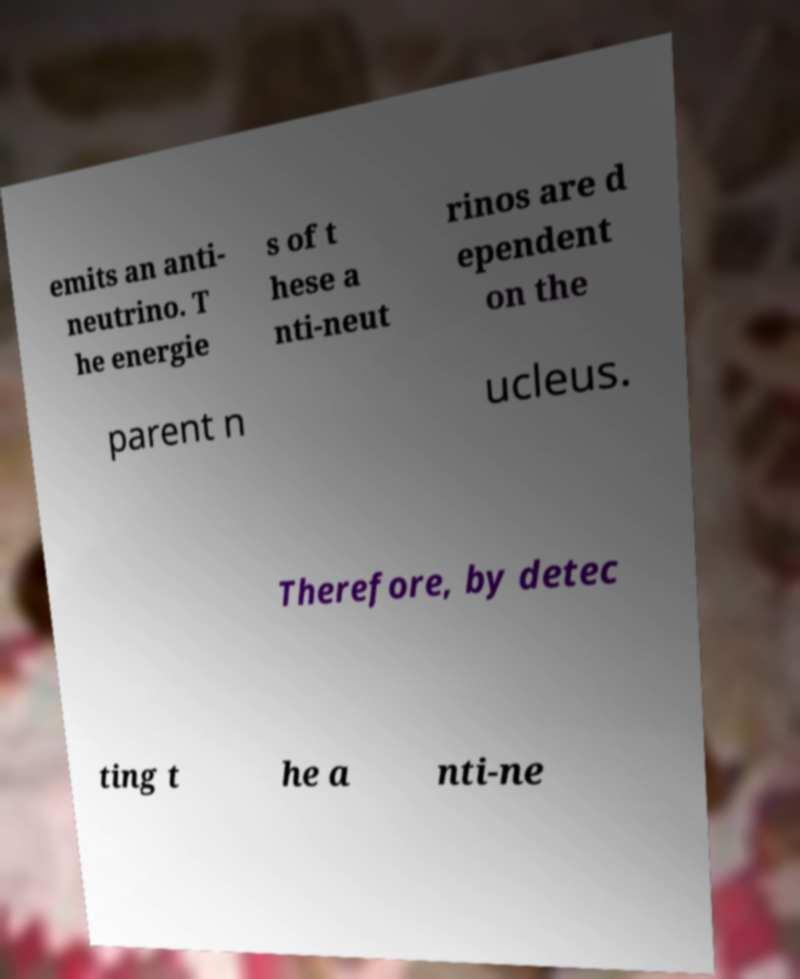Could you assist in decoding the text presented in this image and type it out clearly? emits an anti- neutrino. T he energie s of t hese a nti-neut rinos are d ependent on the parent n ucleus. Therefore, by detec ting t he a nti-ne 